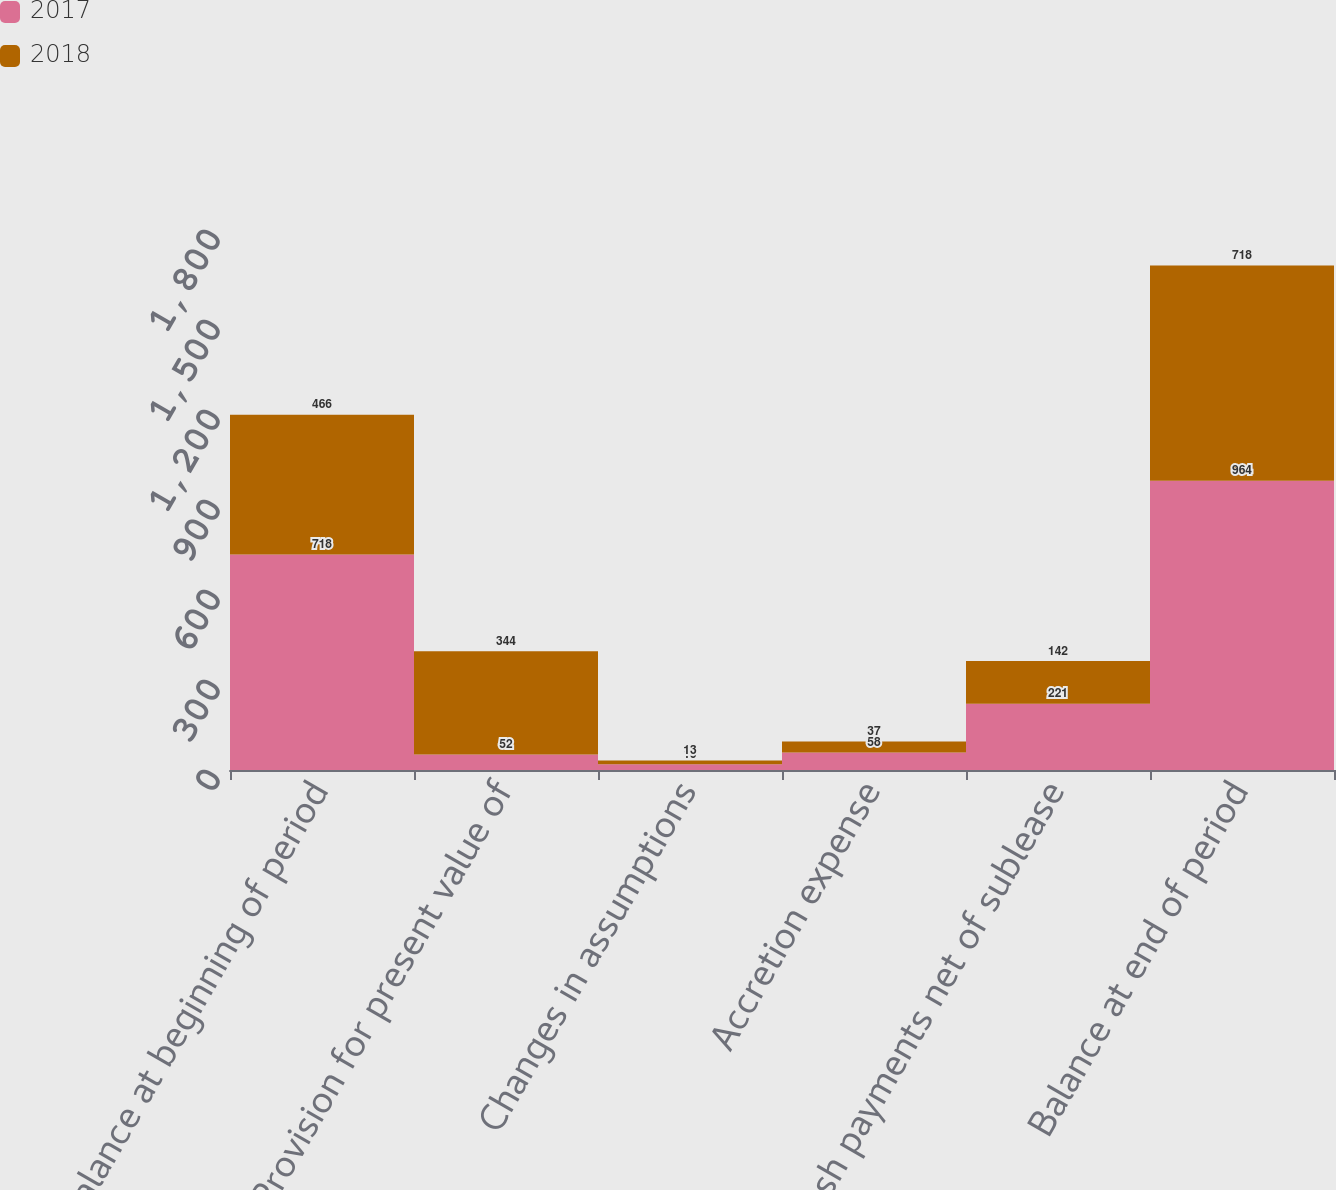<chart> <loc_0><loc_0><loc_500><loc_500><stacked_bar_chart><ecel><fcel>Balance at beginning of period<fcel>Provision for present value of<fcel>Changes in assumptions<fcel>Accretion expense<fcel>Cash payments net of sublease<fcel>Balance at end of period<nl><fcel>2017<fcel>718<fcel>52<fcel>19<fcel>58<fcel>221<fcel>964<nl><fcel>2018<fcel>466<fcel>344<fcel>13<fcel>37<fcel>142<fcel>718<nl></chart> 